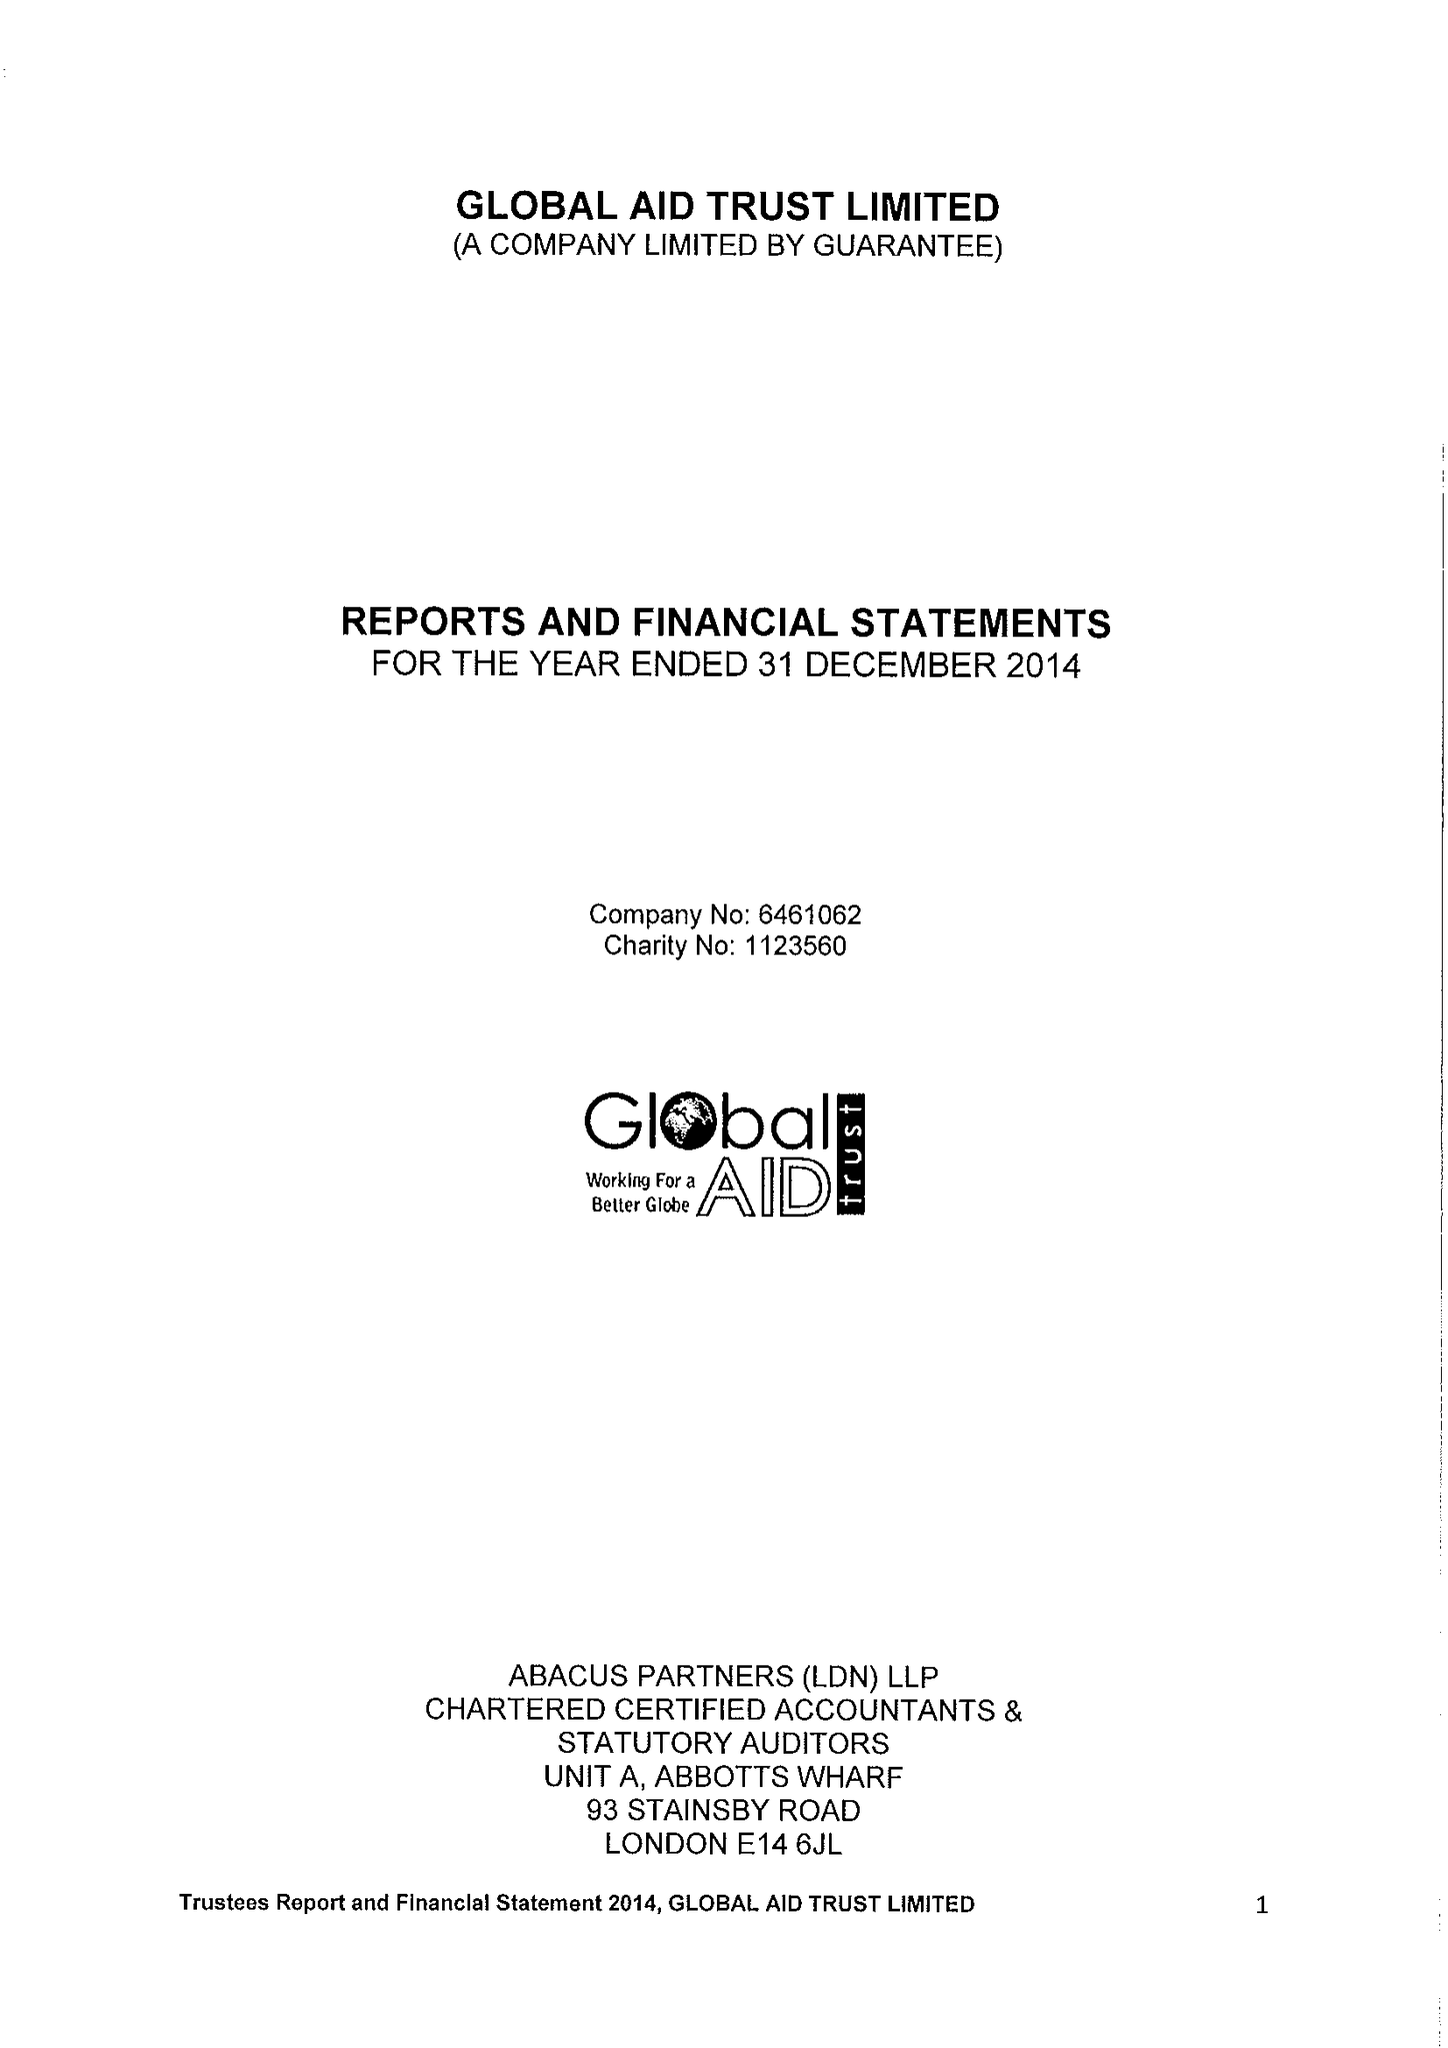What is the value for the address__post_town?
Answer the question using a single word or phrase. LONDON 